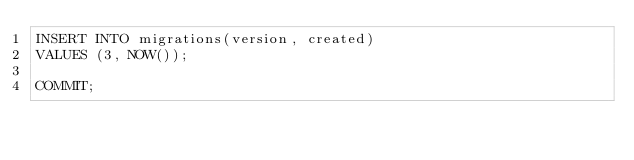<code> <loc_0><loc_0><loc_500><loc_500><_SQL_>INSERT INTO migrations(version, created)
VALUES (3, NOW());

COMMIT;
</code> 